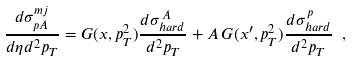Convert formula to latex. <formula><loc_0><loc_0><loc_500><loc_500>\frac { d \sigma ^ { m j } _ { p A } } { d \eta d ^ { 2 } p _ { T } } = G ( x , p _ { T } ^ { 2 } ) \frac { d \sigma ^ { \, A } _ { h a r d } } { d ^ { 2 } p _ { T } } + A \, G ( x ^ { \prime } , p _ { T } ^ { 2 } ) \frac { d \sigma ^ { \, p } _ { h a r d } } { d ^ { 2 } p _ { T } } \ ,</formula> 